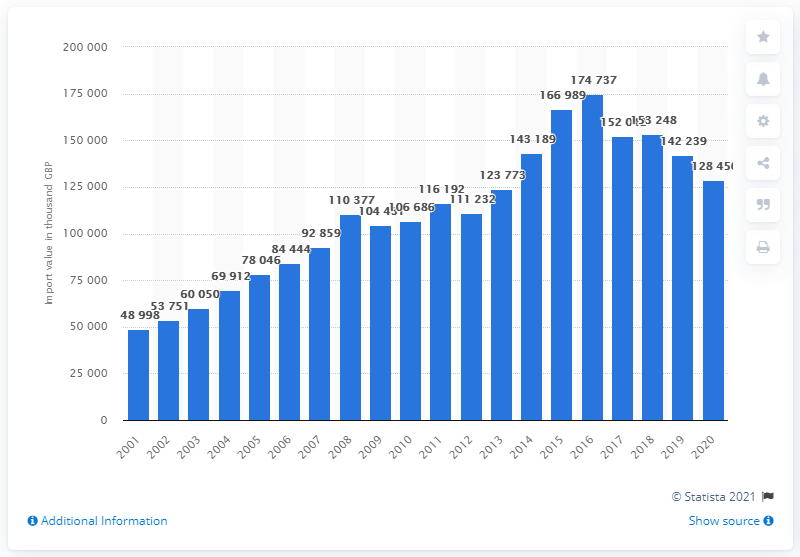Mention a couple of crucial points in this snapshot. In 2016, the peak year for dried fruit exports was reached. 